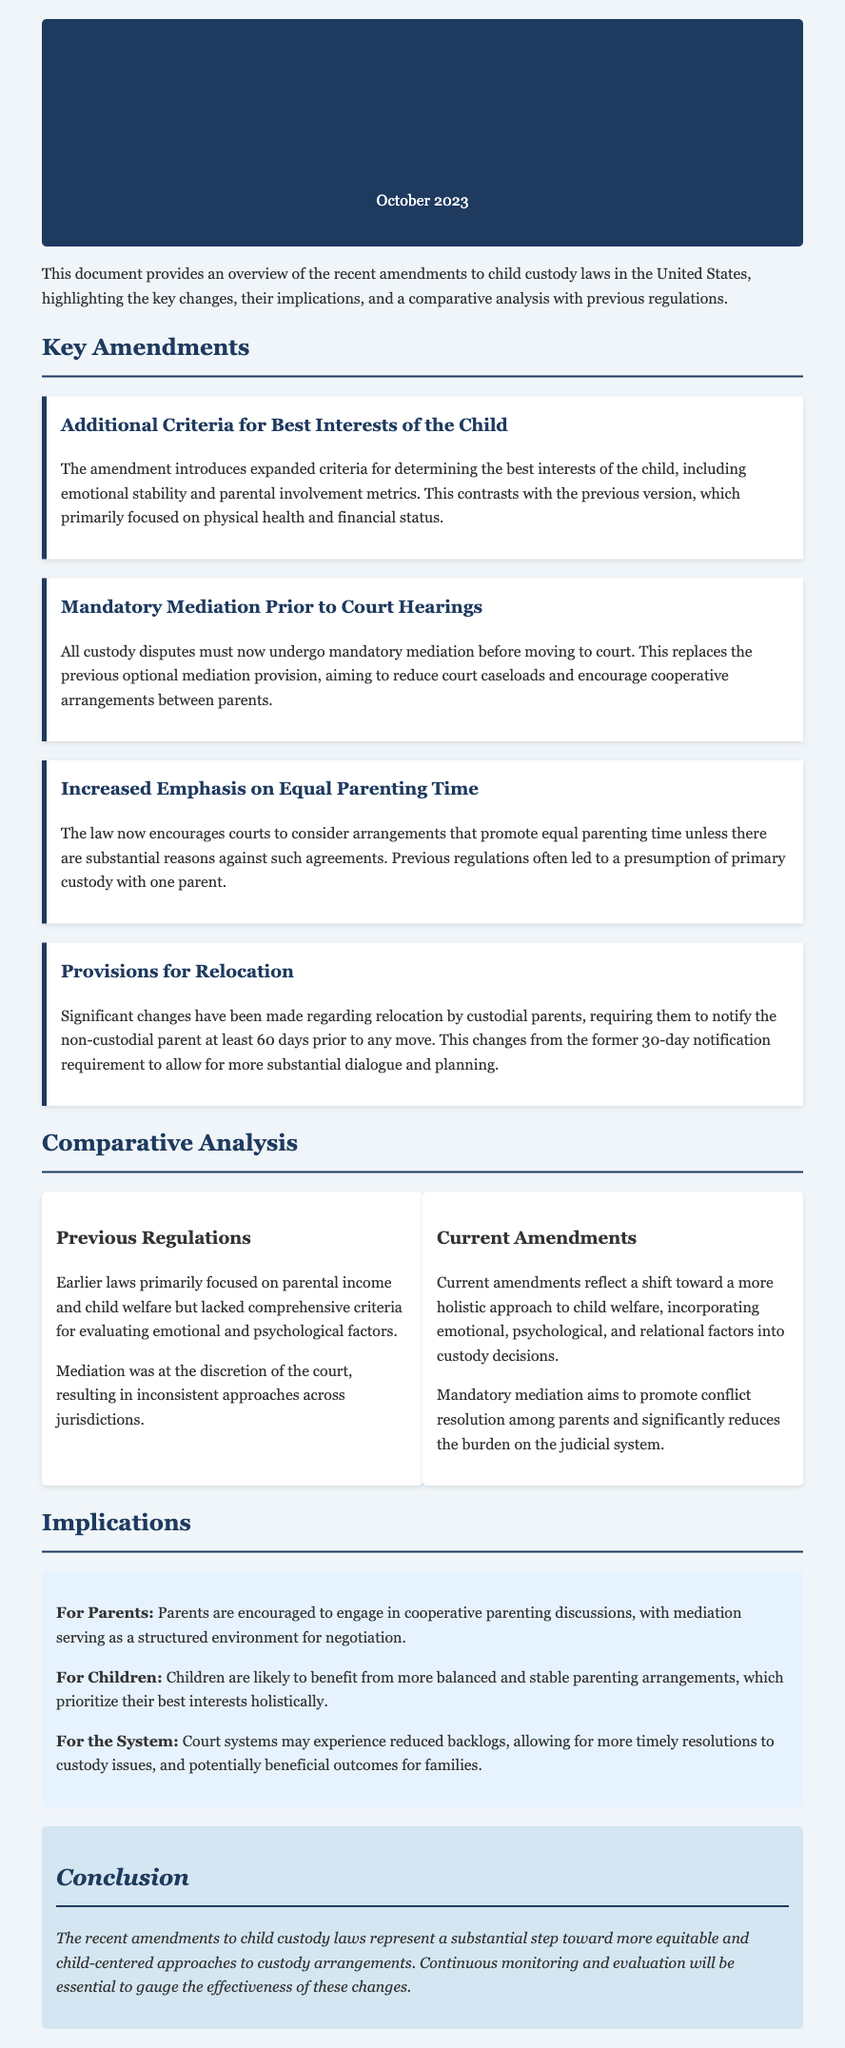What are the key amendments introduced in October 2023? The key amendments introduced include additional criteria for best interests of the child, mandatory mediation prior to court hearings, increased emphasis on equal parenting time, and provisions for relocation.
Answer: Additional criteria for best interests of the child, mandatory mediation prior to court hearings, increased emphasis on equal parenting time, provisions for relocation What is the main purpose of mandatory mediation? The main purpose of mandatory mediation is to reduce court caseloads and encourage cooperative arrangements between parents before moving to court.
Answer: To reduce court caseloads and encourage cooperative arrangements What is the new notification period for custodial parents planning to relocate? The new notification period for custodial parents is 60 days prior to any move, an increase from the previous requirement.
Answer: 60 days How do the current amendments differ regarding emotional and psychological factors? Current amendments incorporate emotional, psychological, and relational factors into custody decisions, which were lacking in previous regulations.
Answer: They incorporate emotional, psychological, and relational factors What implication do the amendments have for children? Children are likely to benefit from more balanced and stable parenting arrangements that prioritize their best interests.
Answer: More balanced and stable parenting arrangements How did earlier laws approach mediation? Earlier laws made mediation at the discretion of the court, leading to inconsistent approaches across jurisdictions.
Answer: At the discretion of the court What is the overall conclusion regarding the amendments? The overall conclusion is that the amendments represent a substantial step toward more equitable and child-centered custody arrangements.
Answer: A substantial step toward more equitable and child-centered custody arrangements 